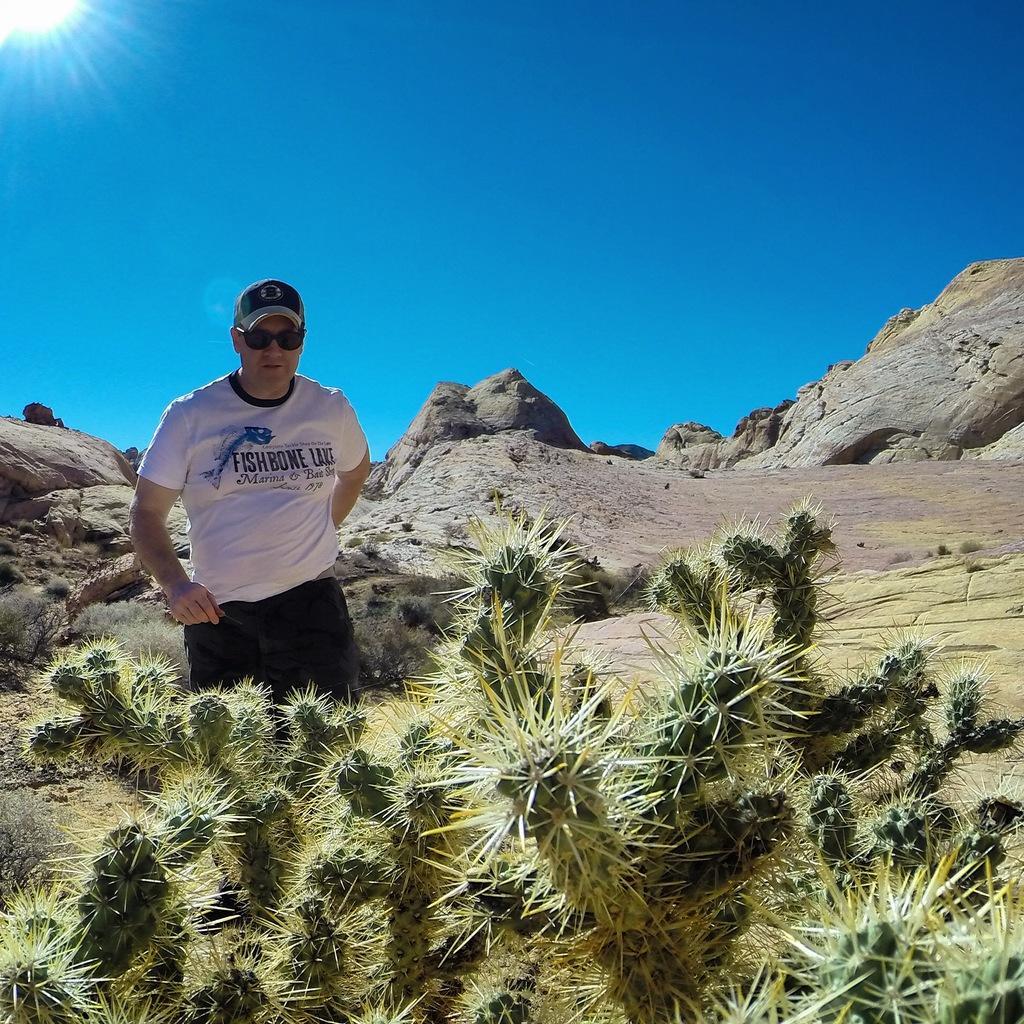Could you give a brief overview of what you see in this image? In the image I can see person is standing. The person is wearing a cap, black color shades, white color T-shirt and black color pant. I can also see plants, mountains and some other objects on the ground. In the background I can see the sun and the sky. 